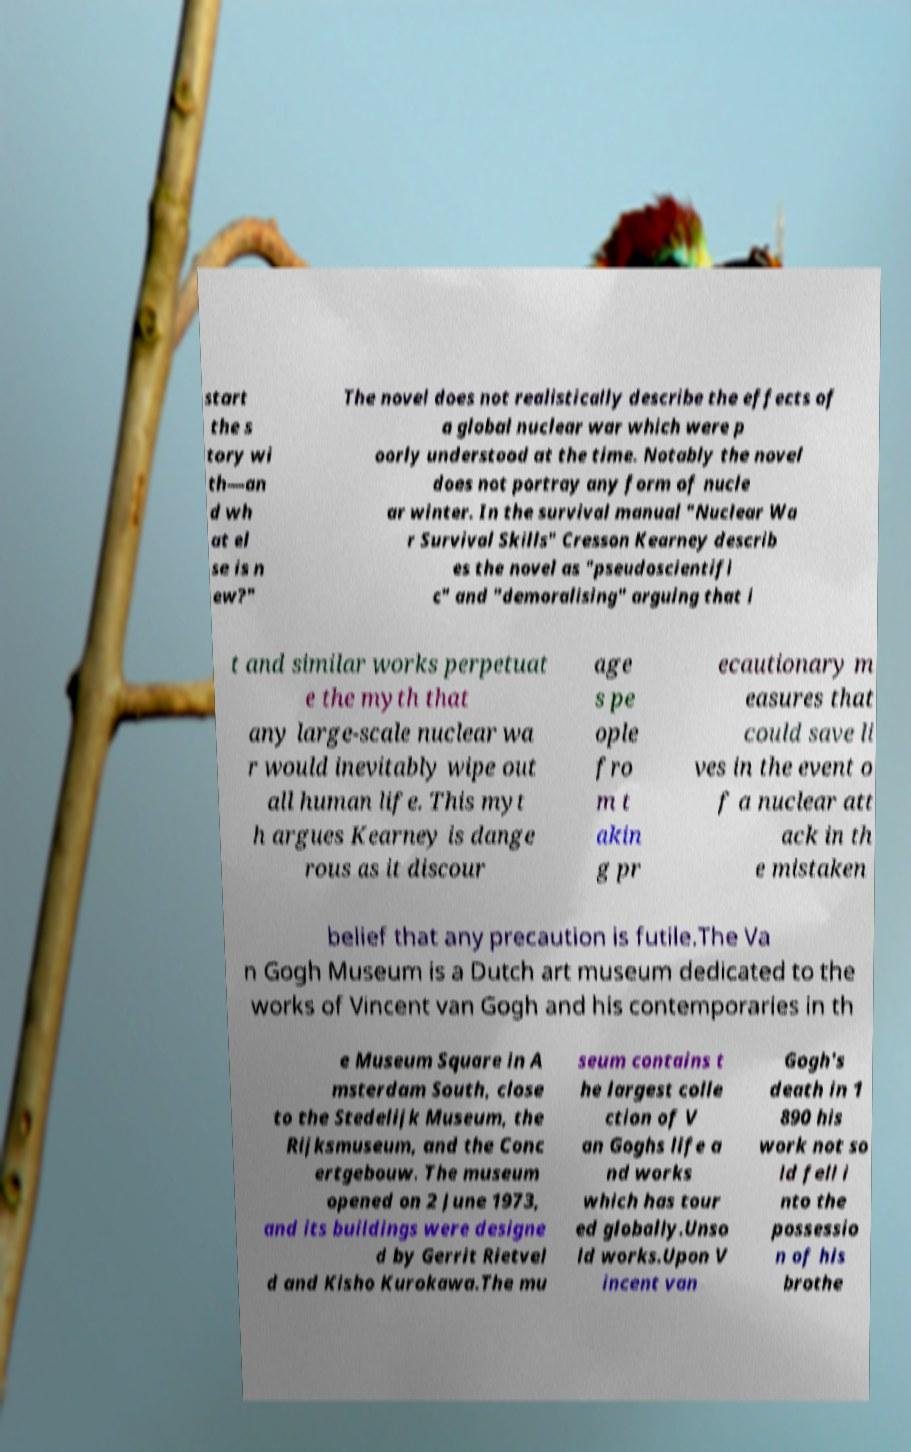There's text embedded in this image that I need extracted. Can you transcribe it verbatim? start the s tory wi th—an d wh at el se is n ew?" The novel does not realistically describe the effects of a global nuclear war which were p oorly understood at the time. Notably the novel does not portray any form of nucle ar winter. In the survival manual "Nuclear Wa r Survival Skills" Cresson Kearney describ es the novel as "pseudoscientifi c" and "demoralising" arguing that i t and similar works perpetuat e the myth that any large-scale nuclear wa r would inevitably wipe out all human life. This myt h argues Kearney is dange rous as it discour age s pe ople fro m t akin g pr ecautionary m easures that could save li ves in the event o f a nuclear att ack in th e mistaken belief that any precaution is futile.The Va n Gogh Museum is a Dutch art museum dedicated to the works of Vincent van Gogh and his contemporaries in th e Museum Square in A msterdam South, close to the Stedelijk Museum, the Rijksmuseum, and the Conc ertgebouw. The museum opened on 2 June 1973, and its buildings were designe d by Gerrit Rietvel d and Kisho Kurokawa.The mu seum contains t he largest colle ction of V an Goghs life a nd works which has tour ed globally.Unso ld works.Upon V incent van Gogh's death in 1 890 his work not so ld fell i nto the possessio n of his brothe 